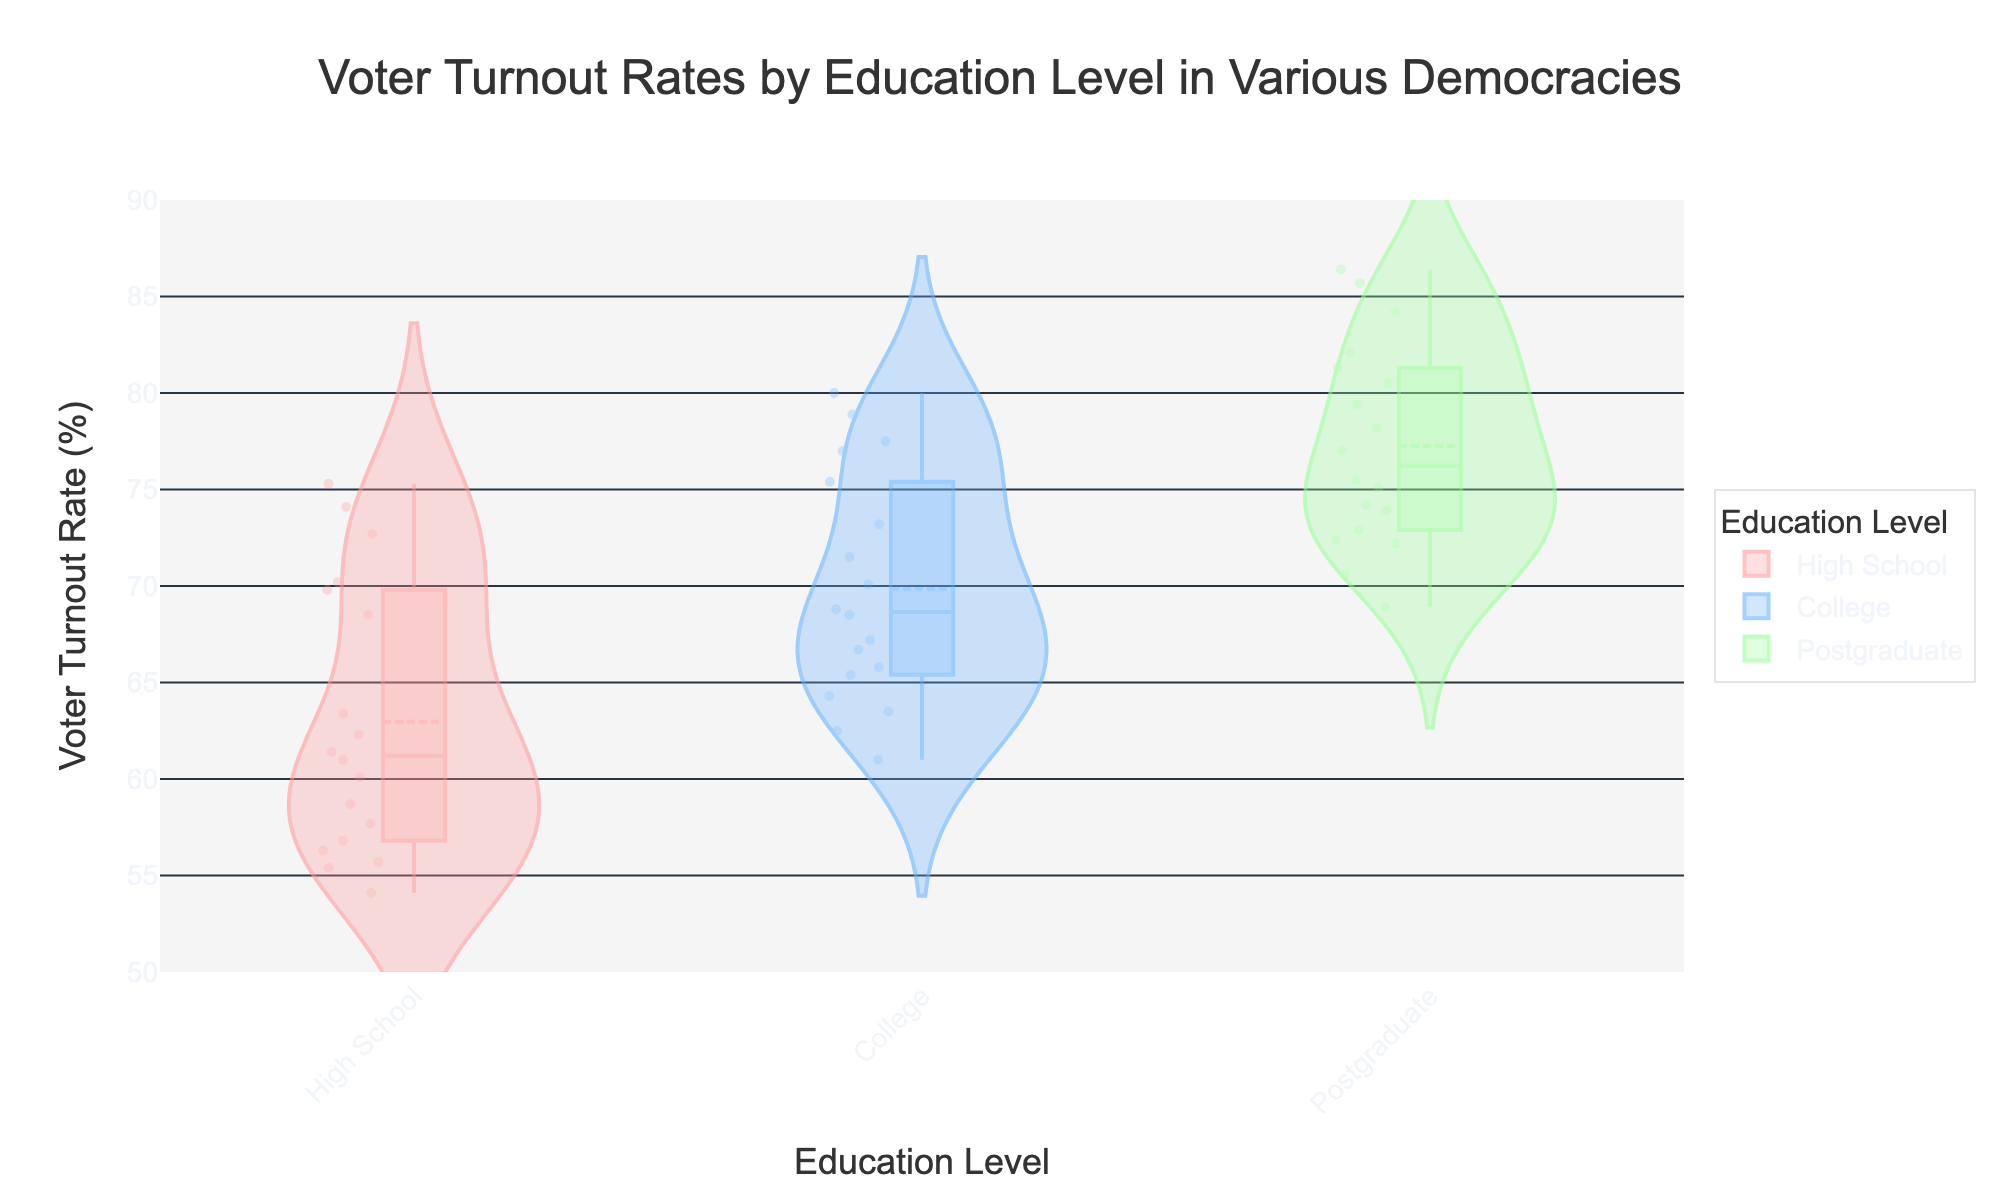What is the title of the figure? The title is written at the top of the figure within the title section. It reads "Voter Turnout Rates by Education Level in Various Democracies."
Answer: Voter Turnout Rates by Education Level in Various Democracies Which education level generally has the highest voter turnout rate? By looking at the positions of the median lines in the violins, Postgraduate seems to have the highest voter turnout rate across all countries.
Answer: Postgraduate What is the color representing the College education level? The color for each education level is indicated by the colors in the legend. The College level is represented with a bluish color (shaded blue or #66B2FF).
Answer: Blue How does the median voter turnout rate for High School education in Germany compare to that in the United States? The median for High School education in Germany can be found by looking at the line within the High School violin for Germany, which is around 70%, while for the United States, it is around 55%. Therefore, the median in Germany is higher than in the United States.
Answer: Higher Which country shows the highest median voter turnout rate for College education? By checking the lines within the College violins, Australia has the highest median voter turnout rate for College education, above 78%.
Answer: Australia What is the range of voter turnout rates for Postgraduate education in Brazil? The range can be determined by looking at the range of the Postgraduate violin plot for Brazil. The values go from around 68.9% to 72.2%.
Answer: 68.9% to 72.2% Is there any country where the voter turnout rate for High School education level overlaps with the Postgraduate level? By examining the distribution and overlap in the violins, no countries show a complete overlap; the violins are generally separated, indicating non-overlapping ranges for High School and Postgraduate education levels.
Answer: No How does the variability of voter turnout rates for Postgraduate education compare to High School education across all countries? Variability can be assessed by comparing the width of the violins. The Postgraduate violins tend to be narrower, indicating lower variability, whereas the High School violins are generally wider, indicating higher variability.
Answer: Lower for Postgraduate What pattern can you observe regarding voter turnout rates and education levels across these democracies? Analyzing the medians and distributions of all the violins, it is clear that higher education levels (College and Postgraduate) consistently show higher voter turnout rates compared to High School education levels.
Answer: Higher turnout with higher education levels 